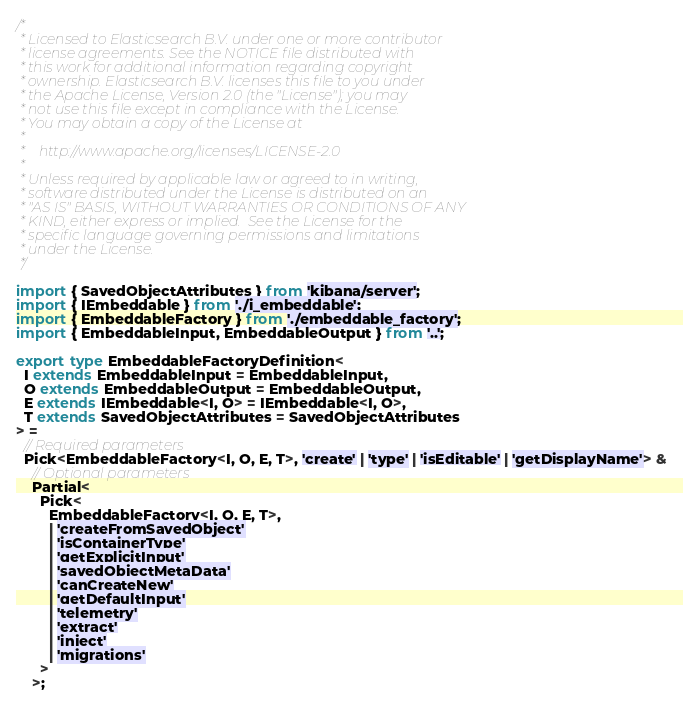Convert code to text. <code><loc_0><loc_0><loc_500><loc_500><_TypeScript_>/*
 * Licensed to Elasticsearch B.V. under one or more contributor
 * license agreements. See the NOTICE file distributed with
 * this work for additional information regarding copyright
 * ownership. Elasticsearch B.V. licenses this file to you under
 * the Apache License, Version 2.0 (the "License"); you may
 * not use this file except in compliance with the License.
 * You may obtain a copy of the License at
 *
 *    http://www.apache.org/licenses/LICENSE-2.0
 *
 * Unless required by applicable law or agreed to in writing,
 * software distributed under the License is distributed on an
 * "AS IS" BASIS, WITHOUT WARRANTIES OR CONDITIONS OF ANY
 * KIND, either express or implied.  See the License for the
 * specific language governing permissions and limitations
 * under the License.
 */

import { SavedObjectAttributes } from 'kibana/server';
import { IEmbeddable } from './i_embeddable';
import { EmbeddableFactory } from './embeddable_factory';
import { EmbeddableInput, EmbeddableOutput } from '..';

export type EmbeddableFactoryDefinition<
  I extends EmbeddableInput = EmbeddableInput,
  O extends EmbeddableOutput = EmbeddableOutput,
  E extends IEmbeddable<I, O> = IEmbeddable<I, O>,
  T extends SavedObjectAttributes = SavedObjectAttributes
> =
  // Required parameters
  Pick<EmbeddableFactory<I, O, E, T>, 'create' | 'type' | 'isEditable' | 'getDisplayName'> &
    // Optional parameters
    Partial<
      Pick<
        EmbeddableFactory<I, O, E, T>,
        | 'createFromSavedObject'
        | 'isContainerType'
        | 'getExplicitInput'
        | 'savedObjectMetaData'
        | 'canCreateNew'
        | 'getDefaultInput'
        | 'telemetry'
        | 'extract'
        | 'inject'
        | 'migrations'
      >
    >;
</code> 